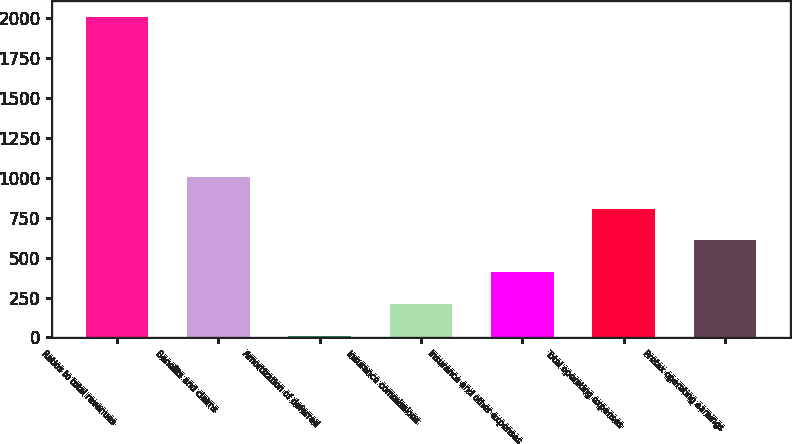Convert chart to OTSL. <chart><loc_0><loc_0><loc_500><loc_500><bar_chart><fcel>Ratios to total revenues<fcel>Benefits and claims<fcel>Amortization of deferred<fcel>Insurance commissions<fcel>Insurance and other expenses<fcel>Total operating expenses<fcel>Pretax operating earnings<nl><fcel>2007<fcel>1007.15<fcel>7.3<fcel>207.27<fcel>407.24<fcel>807.18<fcel>607.21<nl></chart> 